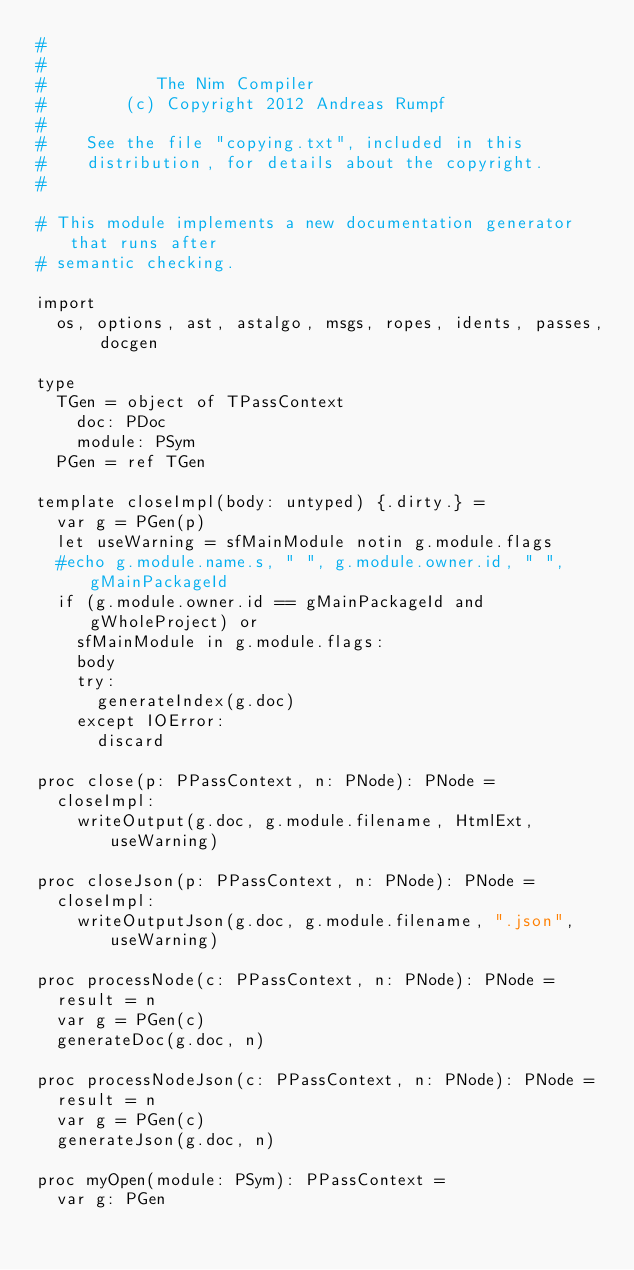Convert code to text. <code><loc_0><loc_0><loc_500><loc_500><_Nim_>#
#
#           The Nim Compiler
#        (c) Copyright 2012 Andreas Rumpf
#
#    See the file "copying.txt", included in this
#    distribution, for details about the copyright.
#

# This module implements a new documentation generator that runs after
# semantic checking.

import
  os, options, ast, astalgo, msgs, ropes, idents, passes, docgen

type
  TGen = object of TPassContext
    doc: PDoc
    module: PSym
  PGen = ref TGen

template closeImpl(body: untyped) {.dirty.} =
  var g = PGen(p)
  let useWarning = sfMainModule notin g.module.flags
  #echo g.module.name.s, " ", g.module.owner.id, " ", gMainPackageId
  if (g.module.owner.id == gMainPackageId and gWholeProject) or
    sfMainModule in g.module.flags:
    body
    try:
      generateIndex(g.doc)
    except IOError:
      discard

proc close(p: PPassContext, n: PNode): PNode =
  closeImpl:
    writeOutput(g.doc, g.module.filename, HtmlExt, useWarning)

proc closeJson(p: PPassContext, n: PNode): PNode =
  closeImpl:
    writeOutputJson(g.doc, g.module.filename, ".json", useWarning)

proc processNode(c: PPassContext, n: PNode): PNode =
  result = n
  var g = PGen(c)
  generateDoc(g.doc, n)

proc processNodeJson(c: PPassContext, n: PNode): PNode =
  result = n
  var g = PGen(c)
  generateJson(g.doc, n)

proc myOpen(module: PSym): PPassContext =
  var g: PGen</code> 